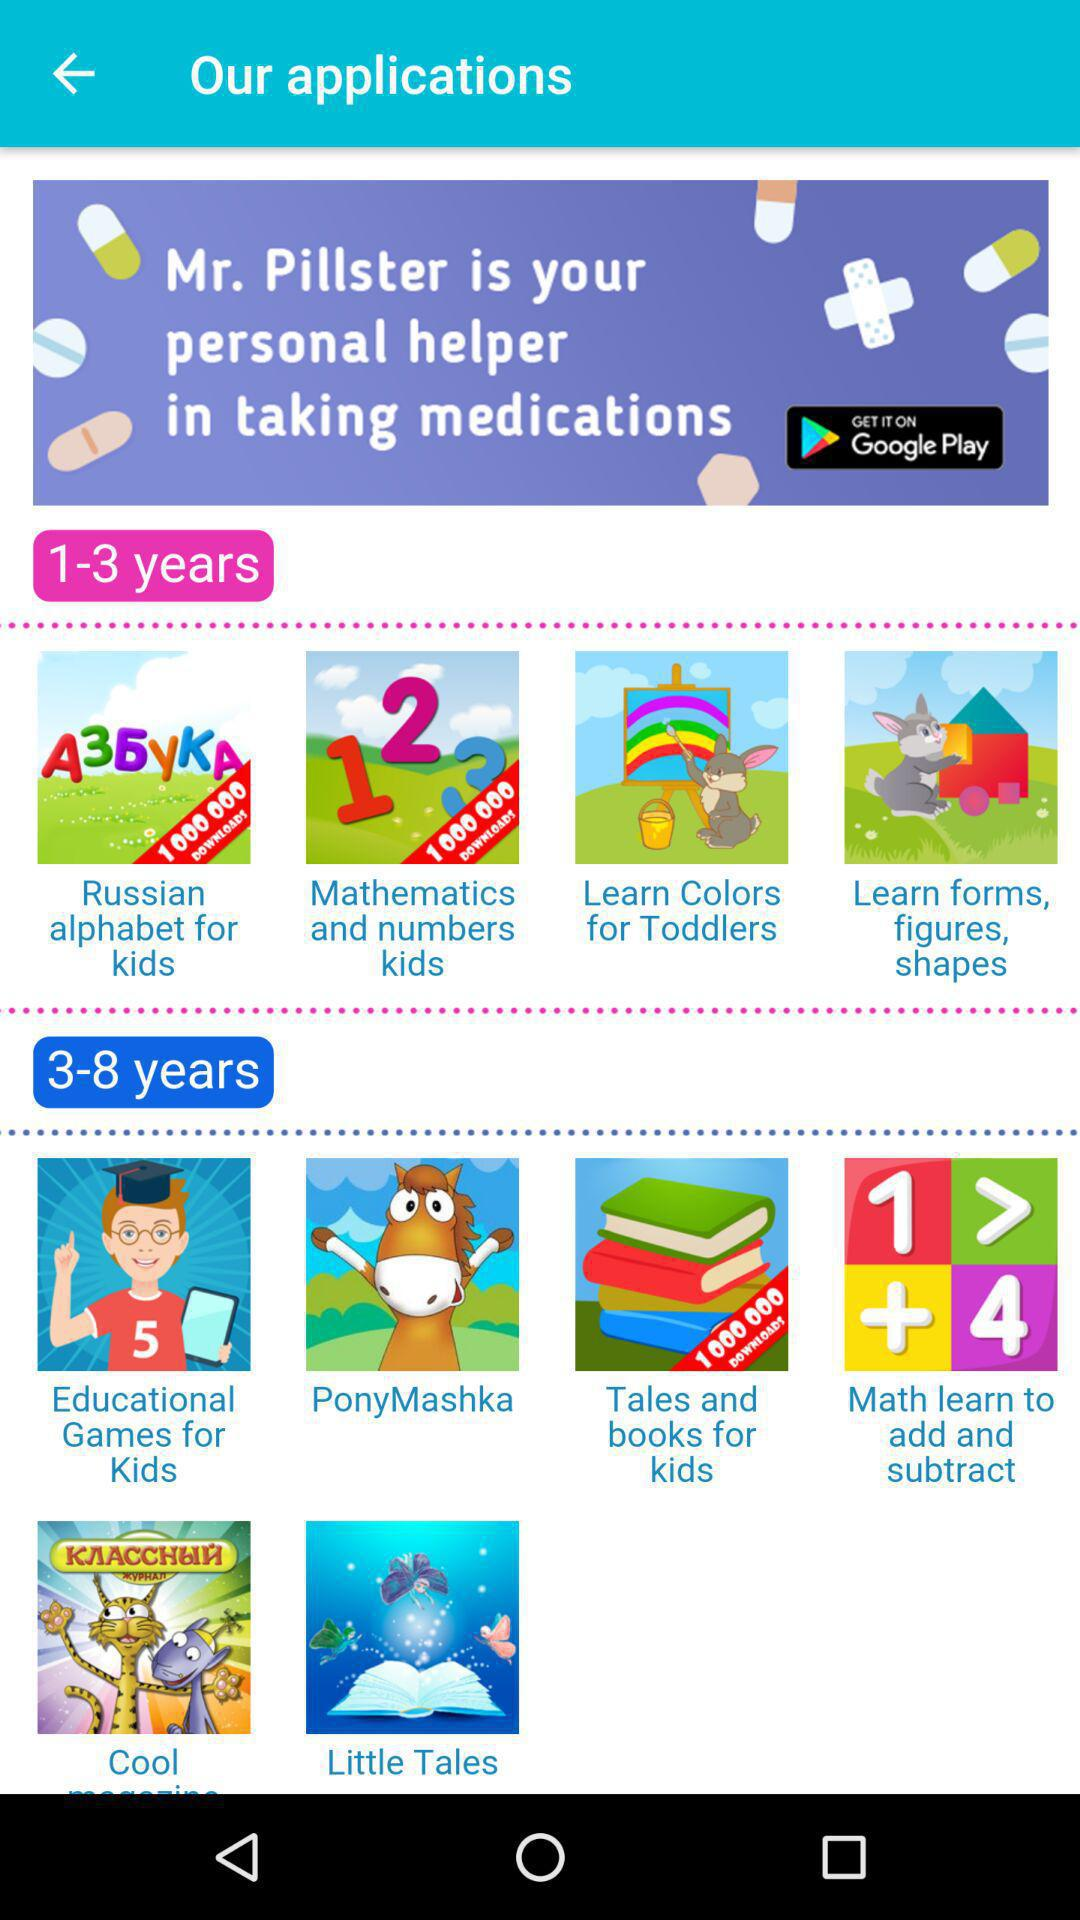Which applications are for 1-3 years old? The application are "Russian alphabet for kids", "Mathematics and numbers kids", "Learn Colors for Toddlers" and "Learn forms, figures, shapes". 